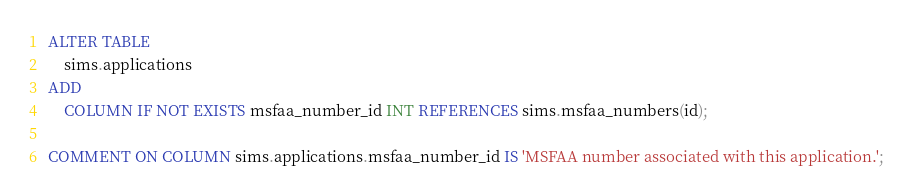<code> <loc_0><loc_0><loc_500><loc_500><_SQL_>ALTER TABLE
    sims.applications
ADD
    COLUMN IF NOT EXISTS msfaa_number_id INT REFERENCES sims.msfaa_numbers(id);

COMMENT ON COLUMN sims.applications.msfaa_number_id IS 'MSFAA number associated with this application.';</code> 